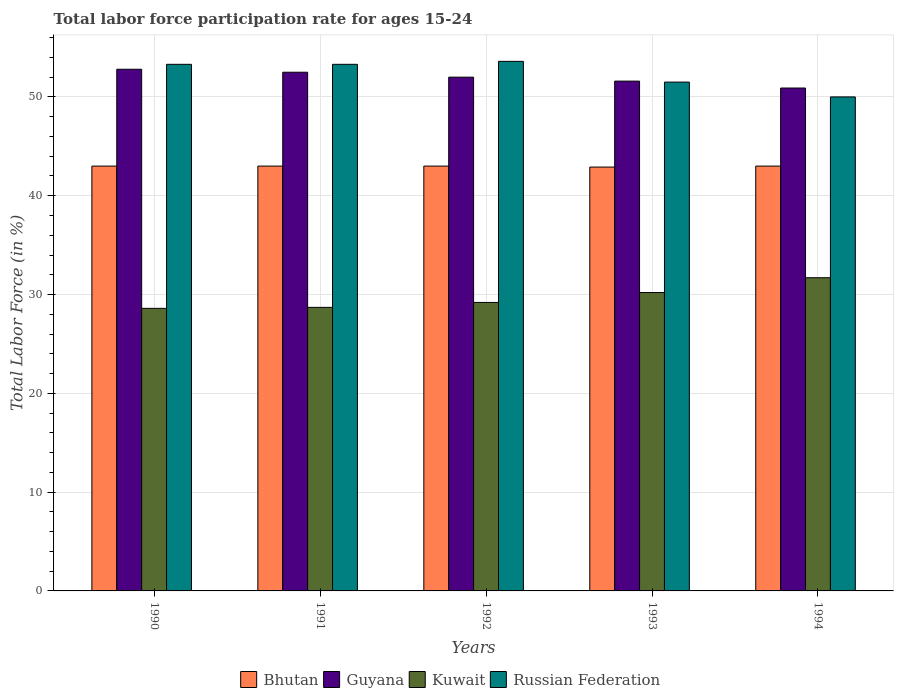How many groups of bars are there?
Make the answer very short. 5. How many bars are there on the 3rd tick from the right?
Ensure brevity in your answer.  4. In how many cases, is the number of bars for a given year not equal to the number of legend labels?
Keep it short and to the point. 0. What is the labor force participation rate in Russian Federation in 1990?
Your answer should be compact. 53.3. Across all years, what is the maximum labor force participation rate in Guyana?
Your answer should be compact. 52.8. Across all years, what is the minimum labor force participation rate in Guyana?
Offer a terse response. 50.9. In which year was the labor force participation rate in Russian Federation minimum?
Make the answer very short. 1994. What is the total labor force participation rate in Kuwait in the graph?
Offer a very short reply. 148.4. What is the difference between the labor force participation rate in Guyana in 1993 and that in 1994?
Give a very brief answer. 0.7. What is the difference between the labor force participation rate in Russian Federation in 1994 and the labor force participation rate in Bhutan in 1990?
Provide a short and direct response. 7. What is the average labor force participation rate in Kuwait per year?
Offer a very short reply. 29.68. In the year 1990, what is the difference between the labor force participation rate in Bhutan and labor force participation rate in Russian Federation?
Offer a terse response. -10.3. In how many years, is the labor force participation rate in Russian Federation greater than 10 %?
Make the answer very short. 5. What is the ratio of the labor force participation rate in Guyana in 1991 to that in 1992?
Offer a terse response. 1.01. Is the difference between the labor force participation rate in Bhutan in 1990 and 1993 greater than the difference between the labor force participation rate in Russian Federation in 1990 and 1993?
Your answer should be very brief. No. What is the difference between the highest and the second highest labor force participation rate in Russian Federation?
Offer a very short reply. 0.3. What is the difference between the highest and the lowest labor force participation rate in Russian Federation?
Provide a short and direct response. 3.6. In how many years, is the labor force participation rate in Guyana greater than the average labor force participation rate in Guyana taken over all years?
Provide a succinct answer. 3. Is it the case that in every year, the sum of the labor force participation rate in Bhutan and labor force participation rate in Guyana is greater than the sum of labor force participation rate in Kuwait and labor force participation rate in Russian Federation?
Your response must be concise. No. What does the 4th bar from the left in 1991 represents?
Keep it short and to the point. Russian Federation. What does the 3rd bar from the right in 1990 represents?
Your answer should be compact. Guyana. Are the values on the major ticks of Y-axis written in scientific E-notation?
Make the answer very short. No. Does the graph contain any zero values?
Your answer should be compact. No. Does the graph contain grids?
Keep it short and to the point. Yes. Where does the legend appear in the graph?
Provide a succinct answer. Bottom center. How many legend labels are there?
Provide a short and direct response. 4. What is the title of the graph?
Keep it short and to the point. Total labor force participation rate for ages 15-24. Does "Cameroon" appear as one of the legend labels in the graph?
Keep it short and to the point. No. What is the Total Labor Force (in %) of Guyana in 1990?
Provide a short and direct response. 52.8. What is the Total Labor Force (in %) of Kuwait in 1990?
Your answer should be very brief. 28.6. What is the Total Labor Force (in %) of Russian Federation in 1990?
Your answer should be compact. 53.3. What is the Total Labor Force (in %) in Bhutan in 1991?
Your answer should be compact. 43. What is the Total Labor Force (in %) in Guyana in 1991?
Your answer should be very brief. 52.5. What is the Total Labor Force (in %) of Kuwait in 1991?
Give a very brief answer. 28.7. What is the Total Labor Force (in %) of Russian Federation in 1991?
Your answer should be compact. 53.3. What is the Total Labor Force (in %) of Guyana in 1992?
Your response must be concise. 52. What is the Total Labor Force (in %) in Kuwait in 1992?
Keep it short and to the point. 29.2. What is the Total Labor Force (in %) of Russian Federation in 1992?
Your answer should be compact. 53.6. What is the Total Labor Force (in %) in Bhutan in 1993?
Your answer should be compact. 42.9. What is the Total Labor Force (in %) in Guyana in 1993?
Make the answer very short. 51.6. What is the Total Labor Force (in %) in Kuwait in 1993?
Offer a terse response. 30.2. What is the Total Labor Force (in %) of Russian Federation in 1993?
Offer a terse response. 51.5. What is the Total Labor Force (in %) of Guyana in 1994?
Give a very brief answer. 50.9. What is the Total Labor Force (in %) in Kuwait in 1994?
Provide a succinct answer. 31.7. Across all years, what is the maximum Total Labor Force (in %) of Bhutan?
Your answer should be compact. 43. Across all years, what is the maximum Total Labor Force (in %) of Guyana?
Make the answer very short. 52.8. Across all years, what is the maximum Total Labor Force (in %) of Kuwait?
Your answer should be compact. 31.7. Across all years, what is the maximum Total Labor Force (in %) in Russian Federation?
Make the answer very short. 53.6. Across all years, what is the minimum Total Labor Force (in %) of Bhutan?
Keep it short and to the point. 42.9. Across all years, what is the minimum Total Labor Force (in %) of Guyana?
Offer a very short reply. 50.9. Across all years, what is the minimum Total Labor Force (in %) of Kuwait?
Provide a succinct answer. 28.6. Across all years, what is the minimum Total Labor Force (in %) of Russian Federation?
Your answer should be very brief. 50. What is the total Total Labor Force (in %) of Bhutan in the graph?
Offer a very short reply. 214.9. What is the total Total Labor Force (in %) of Guyana in the graph?
Your answer should be compact. 259.8. What is the total Total Labor Force (in %) in Kuwait in the graph?
Provide a short and direct response. 148.4. What is the total Total Labor Force (in %) of Russian Federation in the graph?
Offer a terse response. 261.7. What is the difference between the Total Labor Force (in %) in Kuwait in 1990 and that in 1991?
Keep it short and to the point. -0.1. What is the difference between the Total Labor Force (in %) in Russian Federation in 1990 and that in 1991?
Keep it short and to the point. 0. What is the difference between the Total Labor Force (in %) of Bhutan in 1990 and that in 1992?
Your response must be concise. 0. What is the difference between the Total Labor Force (in %) in Russian Federation in 1990 and that in 1992?
Your answer should be compact. -0.3. What is the difference between the Total Labor Force (in %) of Russian Federation in 1990 and that in 1993?
Provide a short and direct response. 1.8. What is the difference between the Total Labor Force (in %) in Guyana in 1990 and that in 1994?
Keep it short and to the point. 1.9. What is the difference between the Total Labor Force (in %) in Kuwait in 1990 and that in 1994?
Offer a very short reply. -3.1. What is the difference between the Total Labor Force (in %) of Bhutan in 1991 and that in 1992?
Offer a very short reply. 0. What is the difference between the Total Labor Force (in %) in Guyana in 1991 and that in 1992?
Offer a terse response. 0.5. What is the difference between the Total Labor Force (in %) of Kuwait in 1991 and that in 1992?
Provide a short and direct response. -0.5. What is the difference between the Total Labor Force (in %) of Russian Federation in 1991 and that in 1992?
Make the answer very short. -0.3. What is the difference between the Total Labor Force (in %) of Bhutan in 1991 and that in 1993?
Your answer should be compact. 0.1. What is the difference between the Total Labor Force (in %) in Guyana in 1991 and that in 1993?
Give a very brief answer. 0.9. What is the difference between the Total Labor Force (in %) in Russian Federation in 1991 and that in 1993?
Offer a terse response. 1.8. What is the difference between the Total Labor Force (in %) in Bhutan in 1991 and that in 1994?
Give a very brief answer. 0. What is the difference between the Total Labor Force (in %) in Guyana in 1991 and that in 1994?
Offer a very short reply. 1.6. What is the difference between the Total Labor Force (in %) of Kuwait in 1991 and that in 1994?
Keep it short and to the point. -3. What is the difference between the Total Labor Force (in %) in Bhutan in 1992 and that in 1993?
Offer a very short reply. 0.1. What is the difference between the Total Labor Force (in %) in Kuwait in 1992 and that in 1993?
Provide a succinct answer. -1. What is the difference between the Total Labor Force (in %) in Russian Federation in 1992 and that in 1993?
Make the answer very short. 2.1. What is the difference between the Total Labor Force (in %) of Bhutan in 1993 and that in 1994?
Your answer should be very brief. -0.1. What is the difference between the Total Labor Force (in %) in Guyana in 1993 and that in 1994?
Provide a short and direct response. 0.7. What is the difference between the Total Labor Force (in %) in Bhutan in 1990 and the Total Labor Force (in %) in Guyana in 1991?
Keep it short and to the point. -9.5. What is the difference between the Total Labor Force (in %) in Bhutan in 1990 and the Total Labor Force (in %) in Kuwait in 1991?
Your answer should be very brief. 14.3. What is the difference between the Total Labor Force (in %) of Guyana in 1990 and the Total Labor Force (in %) of Kuwait in 1991?
Ensure brevity in your answer.  24.1. What is the difference between the Total Labor Force (in %) of Guyana in 1990 and the Total Labor Force (in %) of Russian Federation in 1991?
Your answer should be compact. -0.5. What is the difference between the Total Labor Force (in %) in Kuwait in 1990 and the Total Labor Force (in %) in Russian Federation in 1991?
Your answer should be compact. -24.7. What is the difference between the Total Labor Force (in %) of Bhutan in 1990 and the Total Labor Force (in %) of Guyana in 1992?
Provide a succinct answer. -9. What is the difference between the Total Labor Force (in %) in Bhutan in 1990 and the Total Labor Force (in %) in Russian Federation in 1992?
Keep it short and to the point. -10.6. What is the difference between the Total Labor Force (in %) of Guyana in 1990 and the Total Labor Force (in %) of Kuwait in 1992?
Provide a succinct answer. 23.6. What is the difference between the Total Labor Force (in %) in Guyana in 1990 and the Total Labor Force (in %) in Russian Federation in 1992?
Offer a terse response. -0.8. What is the difference between the Total Labor Force (in %) of Bhutan in 1990 and the Total Labor Force (in %) of Guyana in 1993?
Provide a short and direct response. -8.6. What is the difference between the Total Labor Force (in %) of Bhutan in 1990 and the Total Labor Force (in %) of Kuwait in 1993?
Ensure brevity in your answer.  12.8. What is the difference between the Total Labor Force (in %) in Bhutan in 1990 and the Total Labor Force (in %) in Russian Federation in 1993?
Keep it short and to the point. -8.5. What is the difference between the Total Labor Force (in %) in Guyana in 1990 and the Total Labor Force (in %) in Kuwait in 1993?
Provide a short and direct response. 22.6. What is the difference between the Total Labor Force (in %) of Guyana in 1990 and the Total Labor Force (in %) of Russian Federation in 1993?
Your response must be concise. 1.3. What is the difference between the Total Labor Force (in %) in Kuwait in 1990 and the Total Labor Force (in %) in Russian Federation in 1993?
Your answer should be very brief. -22.9. What is the difference between the Total Labor Force (in %) in Bhutan in 1990 and the Total Labor Force (in %) in Guyana in 1994?
Make the answer very short. -7.9. What is the difference between the Total Labor Force (in %) in Bhutan in 1990 and the Total Labor Force (in %) in Kuwait in 1994?
Provide a short and direct response. 11.3. What is the difference between the Total Labor Force (in %) of Bhutan in 1990 and the Total Labor Force (in %) of Russian Federation in 1994?
Make the answer very short. -7. What is the difference between the Total Labor Force (in %) of Guyana in 1990 and the Total Labor Force (in %) of Kuwait in 1994?
Provide a short and direct response. 21.1. What is the difference between the Total Labor Force (in %) of Guyana in 1990 and the Total Labor Force (in %) of Russian Federation in 1994?
Make the answer very short. 2.8. What is the difference between the Total Labor Force (in %) in Kuwait in 1990 and the Total Labor Force (in %) in Russian Federation in 1994?
Ensure brevity in your answer.  -21.4. What is the difference between the Total Labor Force (in %) in Bhutan in 1991 and the Total Labor Force (in %) in Guyana in 1992?
Provide a succinct answer. -9. What is the difference between the Total Labor Force (in %) of Bhutan in 1991 and the Total Labor Force (in %) of Russian Federation in 1992?
Your response must be concise. -10.6. What is the difference between the Total Labor Force (in %) of Guyana in 1991 and the Total Labor Force (in %) of Kuwait in 1992?
Offer a very short reply. 23.3. What is the difference between the Total Labor Force (in %) in Guyana in 1991 and the Total Labor Force (in %) in Russian Federation in 1992?
Keep it short and to the point. -1.1. What is the difference between the Total Labor Force (in %) of Kuwait in 1991 and the Total Labor Force (in %) of Russian Federation in 1992?
Your answer should be very brief. -24.9. What is the difference between the Total Labor Force (in %) of Bhutan in 1991 and the Total Labor Force (in %) of Guyana in 1993?
Ensure brevity in your answer.  -8.6. What is the difference between the Total Labor Force (in %) in Bhutan in 1991 and the Total Labor Force (in %) in Kuwait in 1993?
Keep it short and to the point. 12.8. What is the difference between the Total Labor Force (in %) in Guyana in 1991 and the Total Labor Force (in %) in Kuwait in 1993?
Ensure brevity in your answer.  22.3. What is the difference between the Total Labor Force (in %) of Kuwait in 1991 and the Total Labor Force (in %) of Russian Federation in 1993?
Offer a terse response. -22.8. What is the difference between the Total Labor Force (in %) in Bhutan in 1991 and the Total Labor Force (in %) in Guyana in 1994?
Provide a short and direct response. -7.9. What is the difference between the Total Labor Force (in %) in Bhutan in 1991 and the Total Labor Force (in %) in Kuwait in 1994?
Provide a succinct answer. 11.3. What is the difference between the Total Labor Force (in %) of Guyana in 1991 and the Total Labor Force (in %) of Kuwait in 1994?
Ensure brevity in your answer.  20.8. What is the difference between the Total Labor Force (in %) in Kuwait in 1991 and the Total Labor Force (in %) in Russian Federation in 1994?
Give a very brief answer. -21.3. What is the difference between the Total Labor Force (in %) of Bhutan in 1992 and the Total Labor Force (in %) of Russian Federation in 1993?
Your answer should be compact. -8.5. What is the difference between the Total Labor Force (in %) in Guyana in 1992 and the Total Labor Force (in %) in Kuwait in 1993?
Provide a succinct answer. 21.8. What is the difference between the Total Labor Force (in %) of Kuwait in 1992 and the Total Labor Force (in %) of Russian Federation in 1993?
Provide a short and direct response. -22.3. What is the difference between the Total Labor Force (in %) of Bhutan in 1992 and the Total Labor Force (in %) of Kuwait in 1994?
Offer a very short reply. 11.3. What is the difference between the Total Labor Force (in %) in Bhutan in 1992 and the Total Labor Force (in %) in Russian Federation in 1994?
Offer a terse response. -7. What is the difference between the Total Labor Force (in %) of Guyana in 1992 and the Total Labor Force (in %) of Kuwait in 1994?
Give a very brief answer. 20.3. What is the difference between the Total Labor Force (in %) of Guyana in 1992 and the Total Labor Force (in %) of Russian Federation in 1994?
Ensure brevity in your answer.  2. What is the difference between the Total Labor Force (in %) of Kuwait in 1992 and the Total Labor Force (in %) of Russian Federation in 1994?
Your response must be concise. -20.8. What is the difference between the Total Labor Force (in %) of Bhutan in 1993 and the Total Labor Force (in %) of Guyana in 1994?
Provide a succinct answer. -8. What is the difference between the Total Labor Force (in %) in Guyana in 1993 and the Total Labor Force (in %) in Russian Federation in 1994?
Make the answer very short. 1.6. What is the difference between the Total Labor Force (in %) of Kuwait in 1993 and the Total Labor Force (in %) of Russian Federation in 1994?
Your answer should be compact. -19.8. What is the average Total Labor Force (in %) of Bhutan per year?
Keep it short and to the point. 42.98. What is the average Total Labor Force (in %) in Guyana per year?
Offer a terse response. 51.96. What is the average Total Labor Force (in %) in Kuwait per year?
Provide a succinct answer. 29.68. What is the average Total Labor Force (in %) in Russian Federation per year?
Provide a succinct answer. 52.34. In the year 1990, what is the difference between the Total Labor Force (in %) of Bhutan and Total Labor Force (in %) of Guyana?
Ensure brevity in your answer.  -9.8. In the year 1990, what is the difference between the Total Labor Force (in %) in Bhutan and Total Labor Force (in %) in Kuwait?
Give a very brief answer. 14.4. In the year 1990, what is the difference between the Total Labor Force (in %) in Guyana and Total Labor Force (in %) in Kuwait?
Offer a terse response. 24.2. In the year 1990, what is the difference between the Total Labor Force (in %) of Guyana and Total Labor Force (in %) of Russian Federation?
Your response must be concise. -0.5. In the year 1990, what is the difference between the Total Labor Force (in %) of Kuwait and Total Labor Force (in %) of Russian Federation?
Make the answer very short. -24.7. In the year 1991, what is the difference between the Total Labor Force (in %) of Guyana and Total Labor Force (in %) of Kuwait?
Your answer should be very brief. 23.8. In the year 1991, what is the difference between the Total Labor Force (in %) of Kuwait and Total Labor Force (in %) of Russian Federation?
Ensure brevity in your answer.  -24.6. In the year 1992, what is the difference between the Total Labor Force (in %) in Bhutan and Total Labor Force (in %) in Guyana?
Offer a terse response. -9. In the year 1992, what is the difference between the Total Labor Force (in %) in Bhutan and Total Labor Force (in %) in Russian Federation?
Your answer should be very brief. -10.6. In the year 1992, what is the difference between the Total Labor Force (in %) in Guyana and Total Labor Force (in %) in Kuwait?
Offer a terse response. 22.8. In the year 1992, what is the difference between the Total Labor Force (in %) of Guyana and Total Labor Force (in %) of Russian Federation?
Offer a terse response. -1.6. In the year 1992, what is the difference between the Total Labor Force (in %) of Kuwait and Total Labor Force (in %) of Russian Federation?
Make the answer very short. -24.4. In the year 1993, what is the difference between the Total Labor Force (in %) of Bhutan and Total Labor Force (in %) of Guyana?
Offer a very short reply. -8.7. In the year 1993, what is the difference between the Total Labor Force (in %) of Guyana and Total Labor Force (in %) of Kuwait?
Make the answer very short. 21.4. In the year 1993, what is the difference between the Total Labor Force (in %) in Kuwait and Total Labor Force (in %) in Russian Federation?
Provide a short and direct response. -21.3. In the year 1994, what is the difference between the Total Labor Force (in %) of Bhutan and Total Labor Force (in %) of Guyana?
Give a very brief answer. -7.9. In the year 1994, what is the difference between the Total Labor Force (in %) in Guyana and Total Labor Force (in %) in Russian Federation?
Ensure brevity in your answer.  0.9. In the year 1994, what is the difference between the Total Labor Force (in %) of Kuwait and Total Labor Force (in %) of Russian Federation?
Ensure brevity in your answer.  -18.3. What is the ratio of the Total Labor Force (in %) in Russian Federation in 1990 to that in 1991?
Your response must be concise. 1. What is the ratio of the Total Labor Force (in %) in Guyana in 1990 to that in 1992?
Offer a terse response. 1.02. What is the ratio of the Total Labor Force (in %) in Kuwait in 1990 to that in 1992?
Provide a succinct answer. 0.98. What is the ratio of the Total Labor Force (in %) of Bhutan in 1990 to that in 1993?
Provide a short and direct response. 1. What is the ratio of the Total Labor Force (in %) of Guyana in 1990 to that in 1993?
Your response must be concise. 1.02. What is the ratio of the Total Labor Force (in %) in Kuwait in 1990 to that in 1993?
Ensure brevity in your answer.  0.95. What is the ratio of the Total Labor Force (in %) of Russian Federation in 1990 to that in 1993?
Keep it short and to the point. 1.03. What is the ratio of the Total Labor Force (in %) in Bhutan in 1990 to that in 1994?
Your answer should be very brief. 1. What is the ratio of the Total Labor Force (in %) of Guyana in 1990 to that in 1994?
Keep it short and to the point. 1.04. What is the ratio of the Total Labor Force (in %) in Kuwait in 1990 to that in 1994?
Offer a very short reply. 0.9. What is the ratio of the Total Labor Force (in %) of Russian Federation in 1990 to that in 1994?
Ensure brevity in your answer.  1.07. What is the ratio of the Total Labor Force (in %) of Guyana in 1991 to that in 1992?
Offer a very short reply. 1.01. What is the ratio of the Total Labor Force (in %) of Kuwait in 1991 to that in 1992?
Keep it short and to the point. 0.98. What is the ratio of the Total Labor Force (in %) in Russian Federation in 1991 to that in 1992?
Make the answer very short. 0.99. What is the ratio of the Total Labor Force (in %) in Bhutan in 1991 to that in 1993?
Give a very brief answer. 1. What is the ratio of the Total Labor Force (in %) in Guyana in 1991 to that in 1993?
Ensure brevity in your answer.  1.02. What is the ratio of the Total Labor Force (in %) of Kuwait in 1991 to that in 1993?
Offer a terse response. 0.95. What is the ratio of the Total Labor Force (in %) of Russian Federation in 1991 to that in 1993?
Give a very brief answer. 1.03. What is the ratio of the Total Labor Force (in %) in Bhutan in 1991 to that in 1994?
Offer a terse response. 1. What is the ratio of the Total Labor Force (in %) in Guyana in 1991 to that in 1994?
Give a very brief answer. 1.03. What is the ratio of the Total Labor Force (in %) in Kuwait in 1991 to that in 1994?
Your answer should be very brief. 0.91. What is the ratio of the Total Labor Force (in %) in Russian Federation in 1991 to that in 1994?
Provide a short and direct response. 1.07. What is the ratio of the Total Labor Force (in %) of Guyana in 1992 to that in 1993?
Offer a very short reply. 1.01. What is the ratio of the Total Labor Force (in %) of Kuwait in 1992 to that in 1993?
Keep it short and to the point. 0.97. What is the ratio of the Total Labor Force (in %) of Russian Federation in 1992 to that in 1993?
Offer a terse response. 1.04. What is the ratio of the Total Labor Force (in %) of Guyana in 1992 to that in 1994?
Provide a short and direct response. 1.02. What is the ratio of the Total Labor Force (in %) of Kuwait in 1992 to that in 1994?
Provide a short and direct response. 0.92. What is the ratio of the Total Labor Force (in %) in Russian Federation in 1992 to that in 1994?
Give a very brief answer. 1.07. What is the ratio of the Total Labor Force (in %) of Guyana in 1993 to that in 1994?
Your answer should be very brief. 1.01. What is the ratio of the Total Labor Force (in %) of Kuwait in 1993 to that in 1994?
Offer a very short reply. 0.95. What is the ratio of the Total Labor Force (in %) in Russian Federation in 1993 to that in 1994?
Make the answer very short. 1.03. What is the difference between the highest and the second highest Total Labor Force (in %) of Russian Federation?
Offer a very short reply. 0.3. What is the difference between the highest and the lowest Total Labor Force (in %) of Bhutan?
Offer a very short reply. 0.1. 